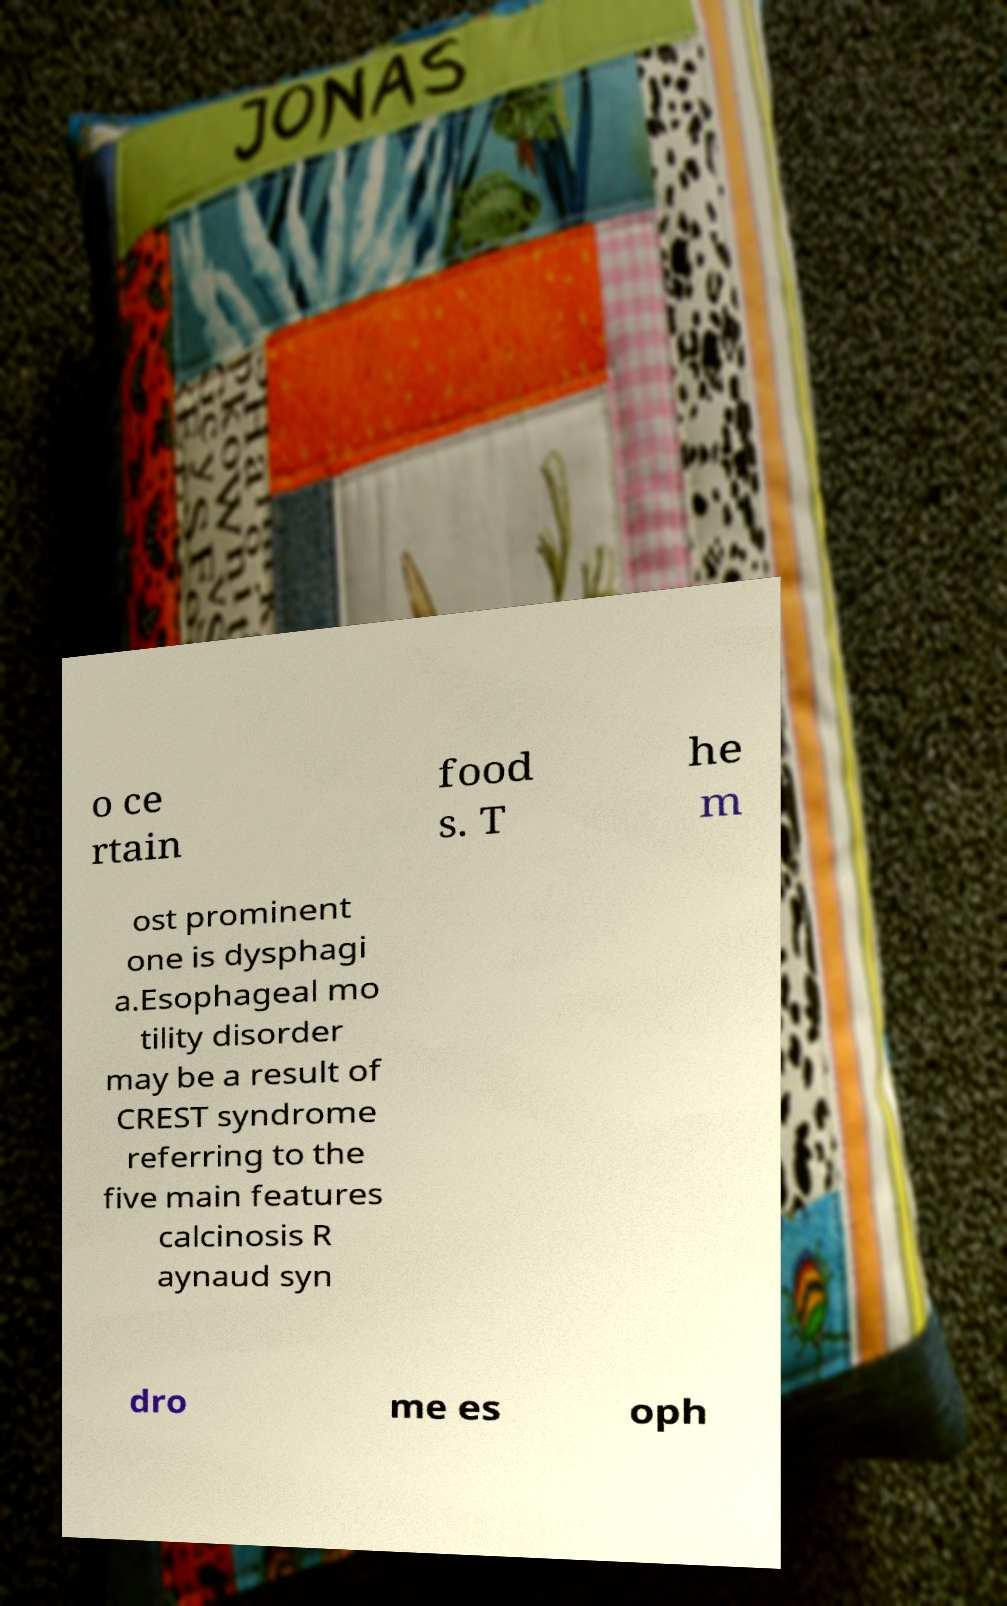I need the written content from this picture converted into text. Can you do that? o ce rtain food s. T he m ost prominent one is dysphagi a.Esophageal mo tility disorder may be a result of CREST syndrome referring to the five main features calcinosis R aynaud syn dro me es oph 